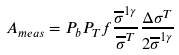Convert formula to latex. <formula><loc_0><loc_0><loc_500><loc_500>A _ { m e a s } = P _ { b } P _ { T } f \frac { { \overline { \sigma } } ^ { 1 \gamma } } { { \overline { \sigma } } ^ { T } } \frac { \Delta \sigma ^ { T } } { 2 { \overline { \sigma } ^ { 1 \gamma } } }</formula> 